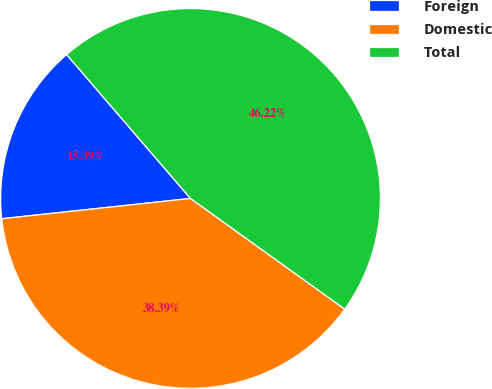<chart> <loc_0><loc_0><loc_500><loc_500><pie_chart><fcel>Foreign<fcel>Domestic<fcel>Total<nl><fcel>15.39%<fcel>38.39%<fcel>46.22%<nl></chart> 